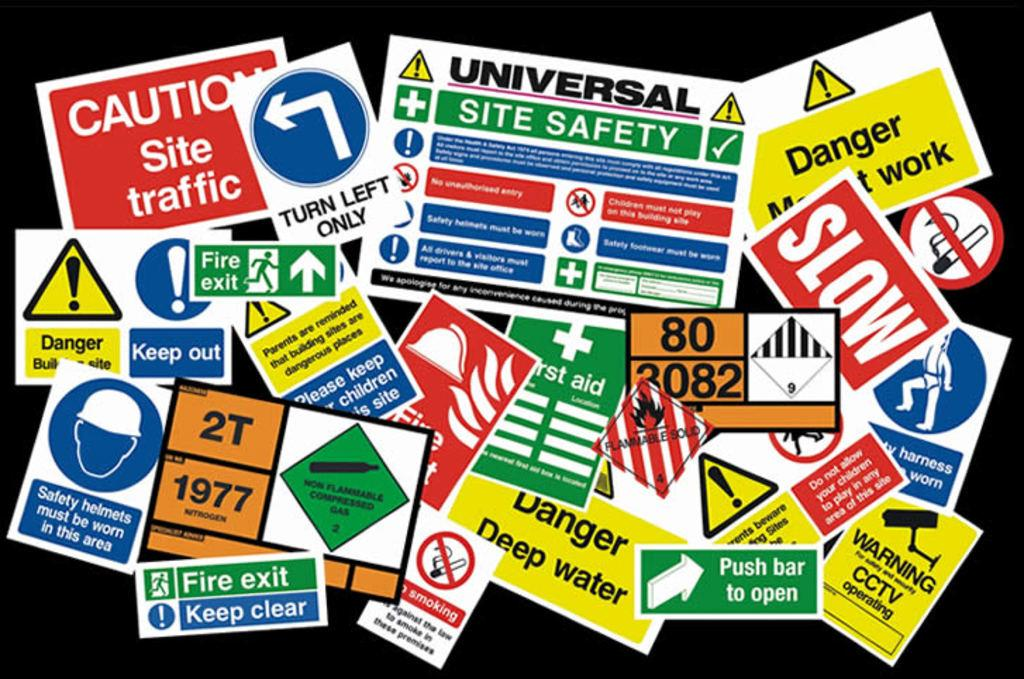<image>
Share a concise interpretation of the image provided. A bunch of signs are in a pile with one warning of deep water. 